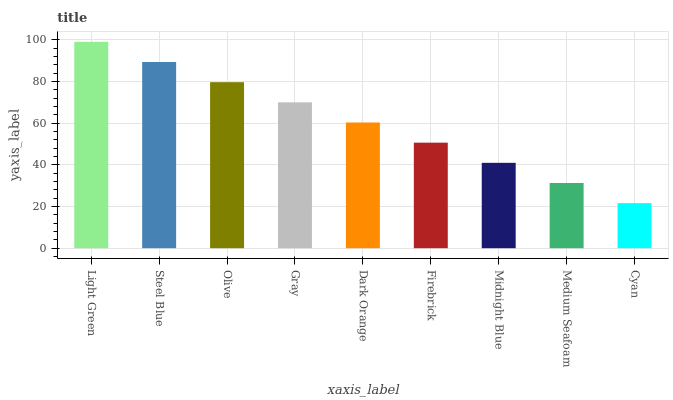Is Cyan the minimum?
Answer yes or no. Yes. Is Light Green the maximum?
Answer yes or no. Yes. Is Steel Blue the minimum?
Answer yes or no. No. Is Steel Blue the maximum?
Answer yes or no. No. Is Light Green greater than Steel Blue?
Answer yes or no. Yes. Is Steel Blue less than Light Green?
Answer yes or no. Yes. Is Steel Blue greater than Light Green?
Answer yes or no. No. Is Light Green less than Steel Blue?
Answer yes or no. No. Is Dark Orange the high median?
Answer yes or no. Yes. Is Dark Orange the low median?
Answer yes or no. Yes. Is Light Green the high median?
Answer yes or no. No. Is Light Green the low median?
Answer yes or no. No. 